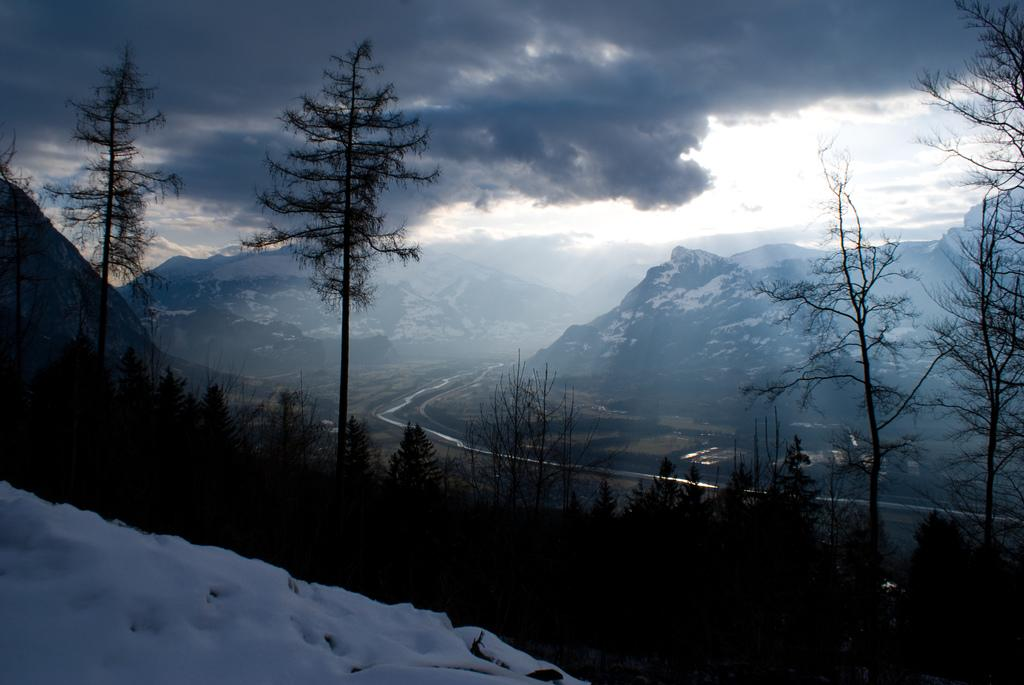What can be seen in the sky in the background of the image? There are clouds in the sky in the background of the image. What type of vegetation is visible in the image? There are trees visible in the image. What is present in the bottom left corner of the image? There is snow in the bottom left corner of the image. What type of plastic material is being taught in the image? There is no plastic material or teaching activity present in the image. What type of education is being provided in the image? There is no educational activity or institution present in the image. 